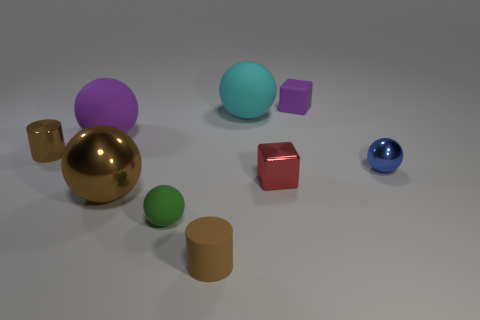Subtract all brown spheres. How many spheres are left? 4 Subtract all green spheres. How many spheres are left? 4 Subtract all yellow spheres. Subtract all green cylinders. How many spheres are left? 5 Subtract all cubes. How many objects are left? 7 Subtract all tiny red shiny objects. Subtract all brown objects. How many objects are left? 5 Add 2 tiny cylinders. How many tiny cylinders are left? 4 Add 8 big rubber things. How many big rubber things exist? 10 Subtract 1 green balls. How many objects are left? 8 